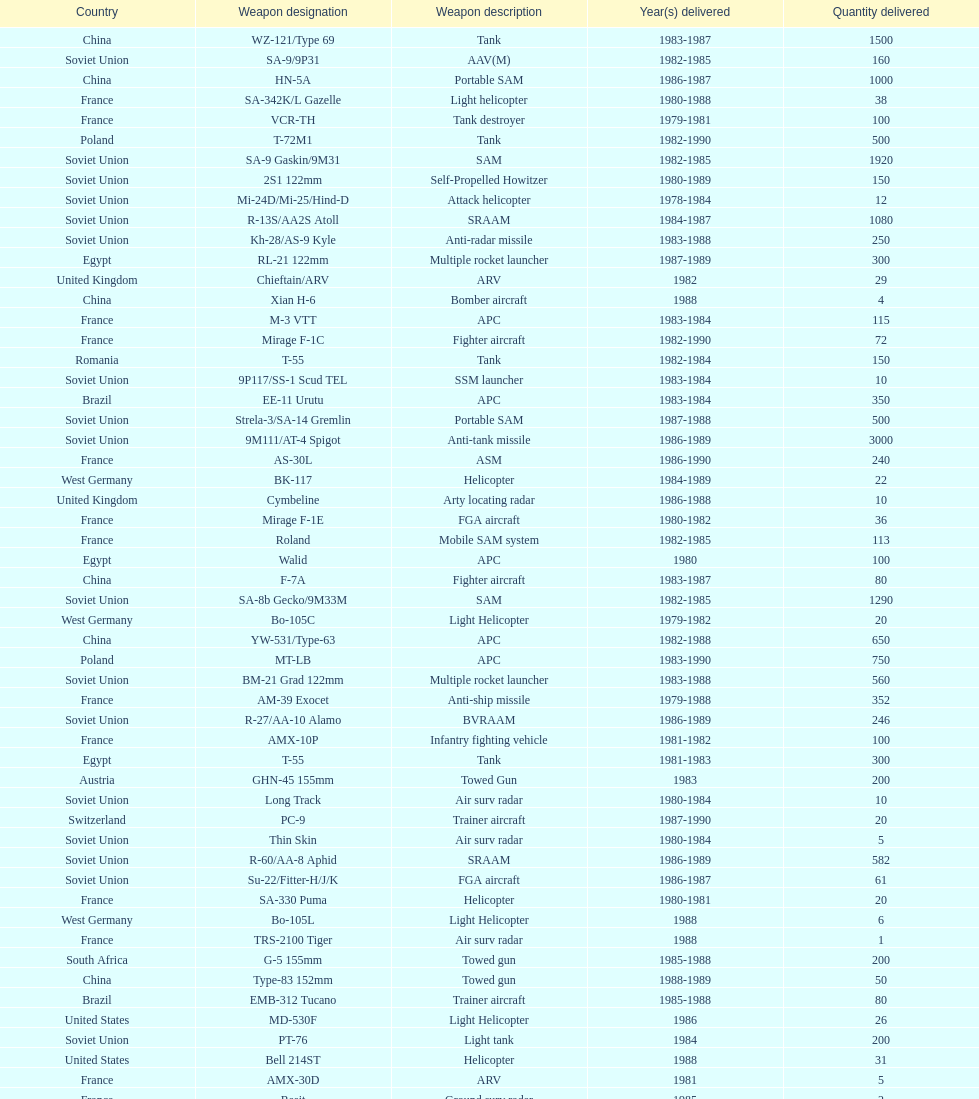Which was the first country to sell weapons to iraq? Czechoslovakia. 